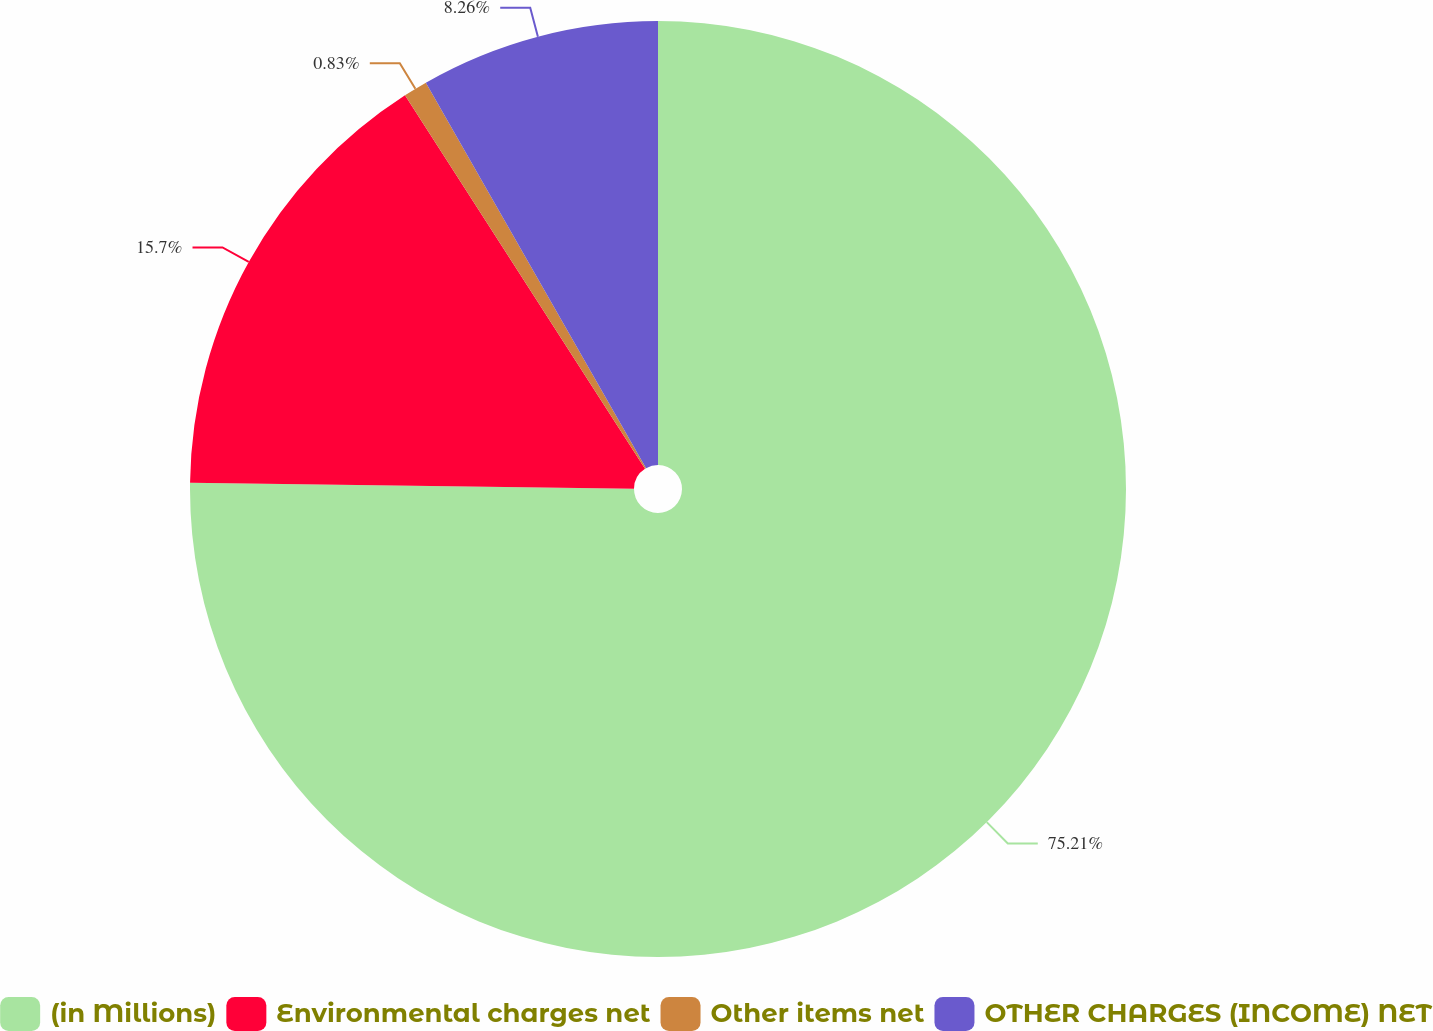Convert chart. <chart><loc_0><loc_0><loc_500><loc_500><pie_chart><fcel>(in Millions)<fcel>Environmental charges net<fcel>Other items net<fcel>OTHER CHARGES (INCOME) NET<nl><fcel>75.21%<fcel>15.7%<fcel>0.83%<fcel>8.26%<nl></chart> 